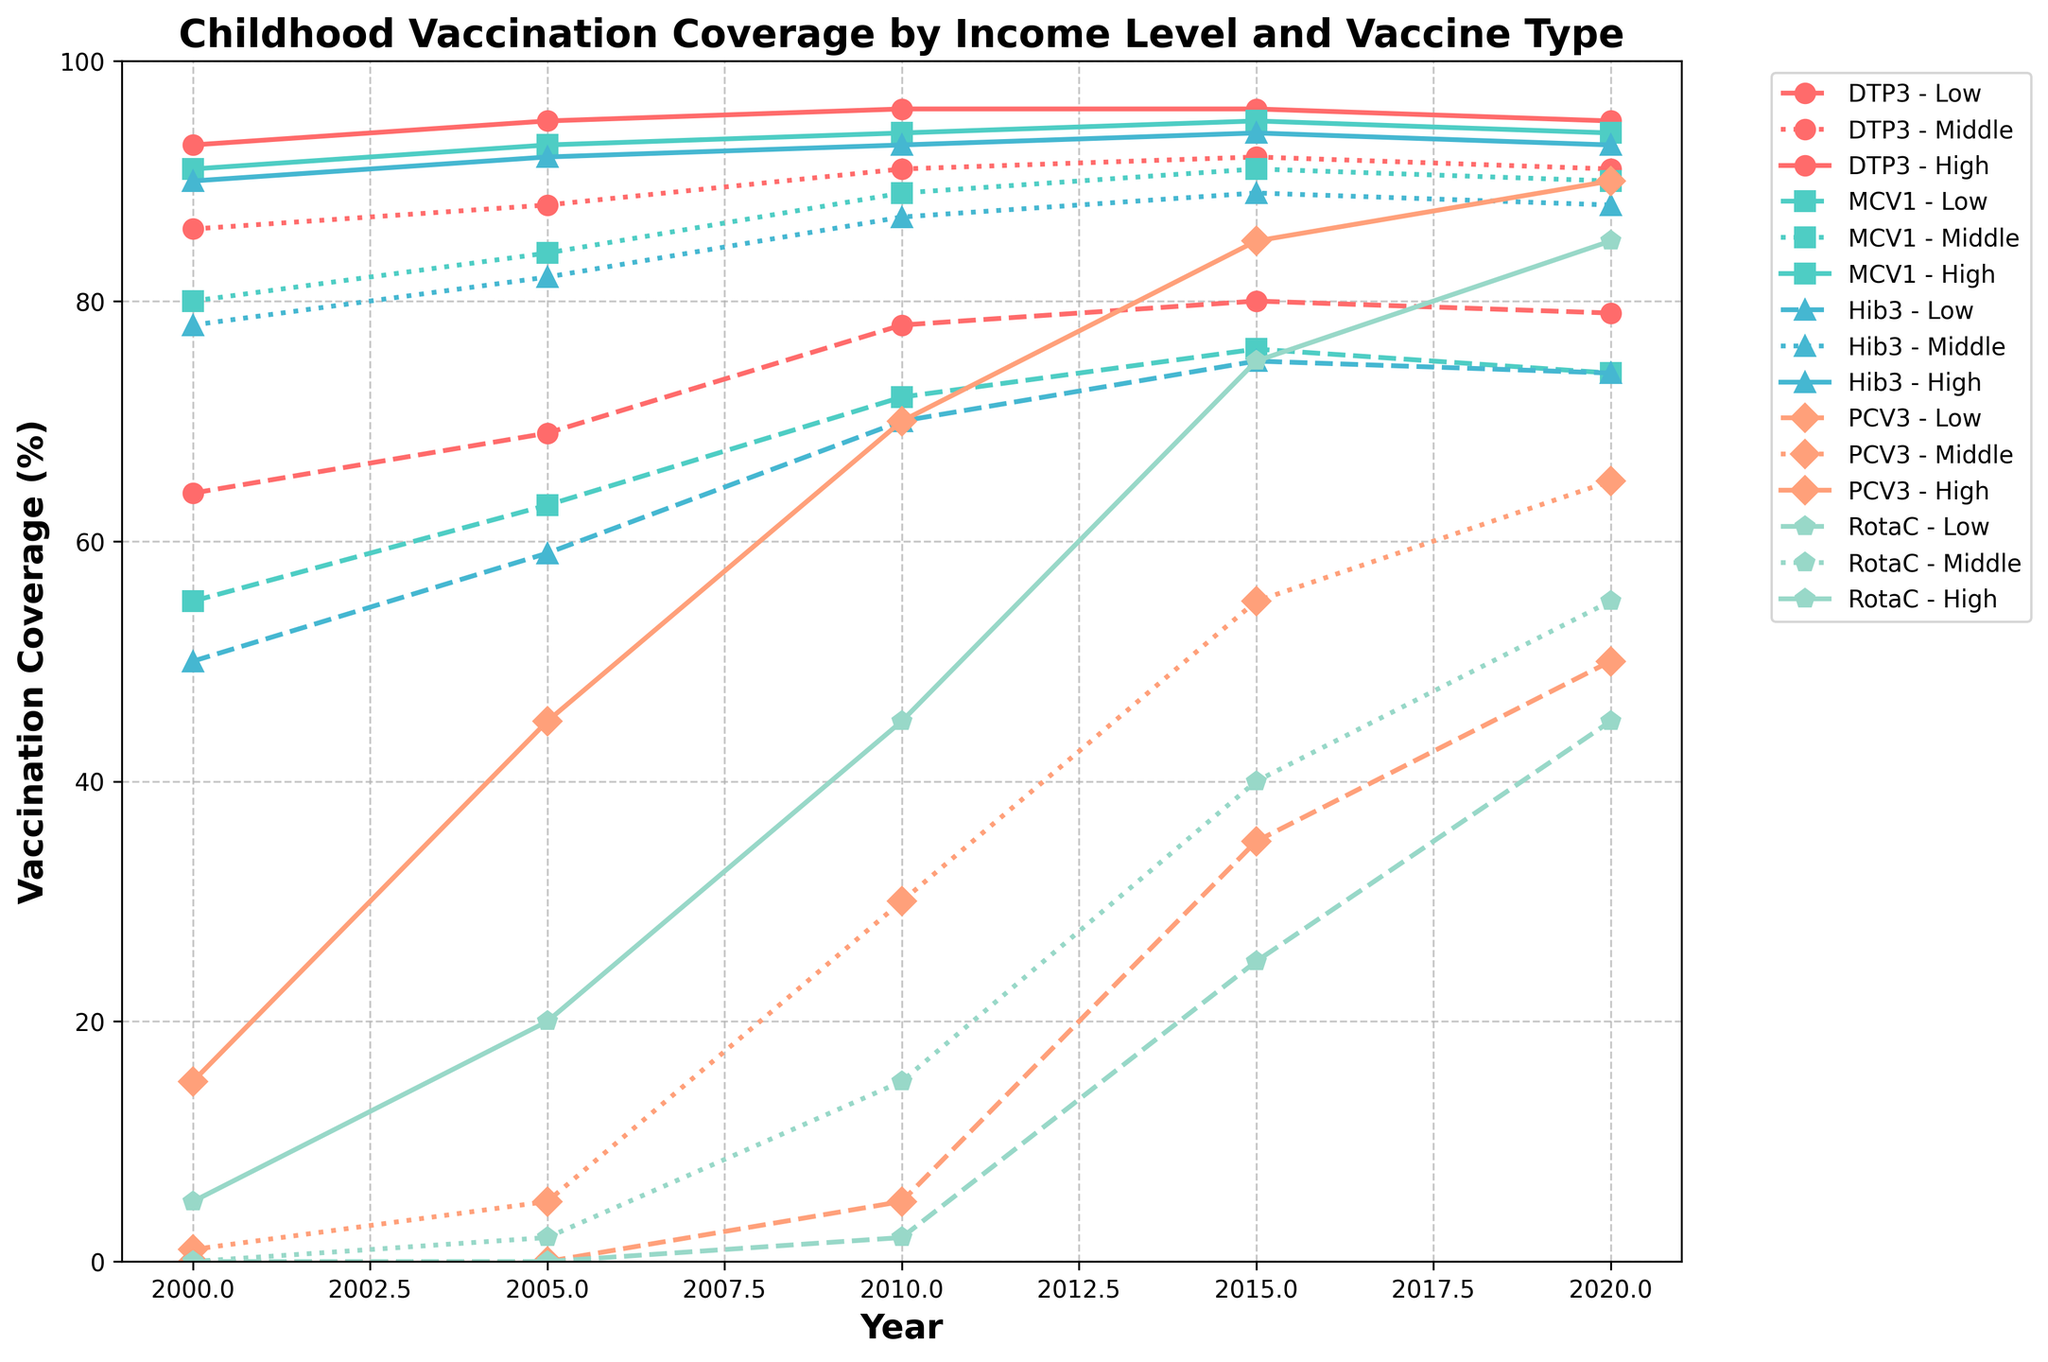What was the vaccination coverage for DTP3 in high-income countries in 2020? Locate the DTP3 line representing high-income countries and find the coverage percentage corresponding to the year 2020. From the figure, find the point where the year 2020 aligns with the high-income line for DTP3. The y-value of this point represents the coverage percentage.
Answer: 95% How much did PCV3 coverage increase from 2000 to 2020 in low-income countries? Find the PCV3 line representing low-income countries and look at the coverage percentage in 2000 and 2020. Calculate the difference between these two percentages: PCV3 coverage in 2000 is 0%, and in 2020, it's 50%. The increase is 50% - 0% = 50%.
Answer: 50% Which vaccine showed the largest increase in coverage in middle-income countries from 2000 to 2020? Compare the changes in vaccination coverage percentages for all vaccines in middle-income countries between 2000 and 2020. For PCV3 in middle-income countries, the increase is from 1% in 2000 to 65% in 2020, which is the largest among all vaccines.
Answer: PCV3 In which year did high-income countries achieve 90% or higher coverage for all vaccines? Examine the high-income country lines for all vaccines to find the first year where all vaccines' coverage percentages are at least 90%. In 2020, DTP3, MCV1, Hib3, PCV3, and RotaC all exceed 90% coverage in high-income countries.
Answer: 2020 Between which years did low-income countries see the highest increase in Hib3 coverage? Compare the coverage increases across the intervals 2000-2005, 2005-2010, 2010-2015, and 2015-2020 for Hib3 in low-income countries. The interval 2005-2010 shows the highest increase, with coverage rising from 59% to 70%, which is an 11% increase, the largest among the intervals.
Answer: 2005-2010 Which vaccine had the smallest difference in coverage between high-income and low-income countries in 2015? For each vaccine in 2015, calculate the difference in coverage between high-income and low-income countries. The differences are as follows: DTP3: 96% - 80% = 16%, MCV1: 95% - 76% = 19%, Hib3: 94% - 75% = 19%, PCV3: 85% - 35% = 50%, RotaC: 75% - 25% = 50%. The smallest difference is for DTP3.
Answer: DTP3 What trend can be observed for PCV3 coverage in middle-income countries over the period 2000-2020? Observe the line representing PCV3 coverage in middle-income countries and note the general direction and pattern. The coverage shows a continuous increase over the years from 1% in 2000 to 65% in 2020, indicating an upward trend.
Answer: Continuous increase Which vaccine had the highest coverage in low-income countries by 2010? Examine the coverage percentages for all vaccines in low-income countries in 2010 and identify the highest value. The highest coverage is for DTP3 at 78%.
Answer: DTP3 